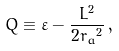Convert formula to latex. <formula><loc_0><loc_0><loc_500><loc_500>Q \equiv \varepsilon - \frac { L ^ { 2 } } { 2 { r _ { a } } ^ { 2 } } \, ,</formula> 